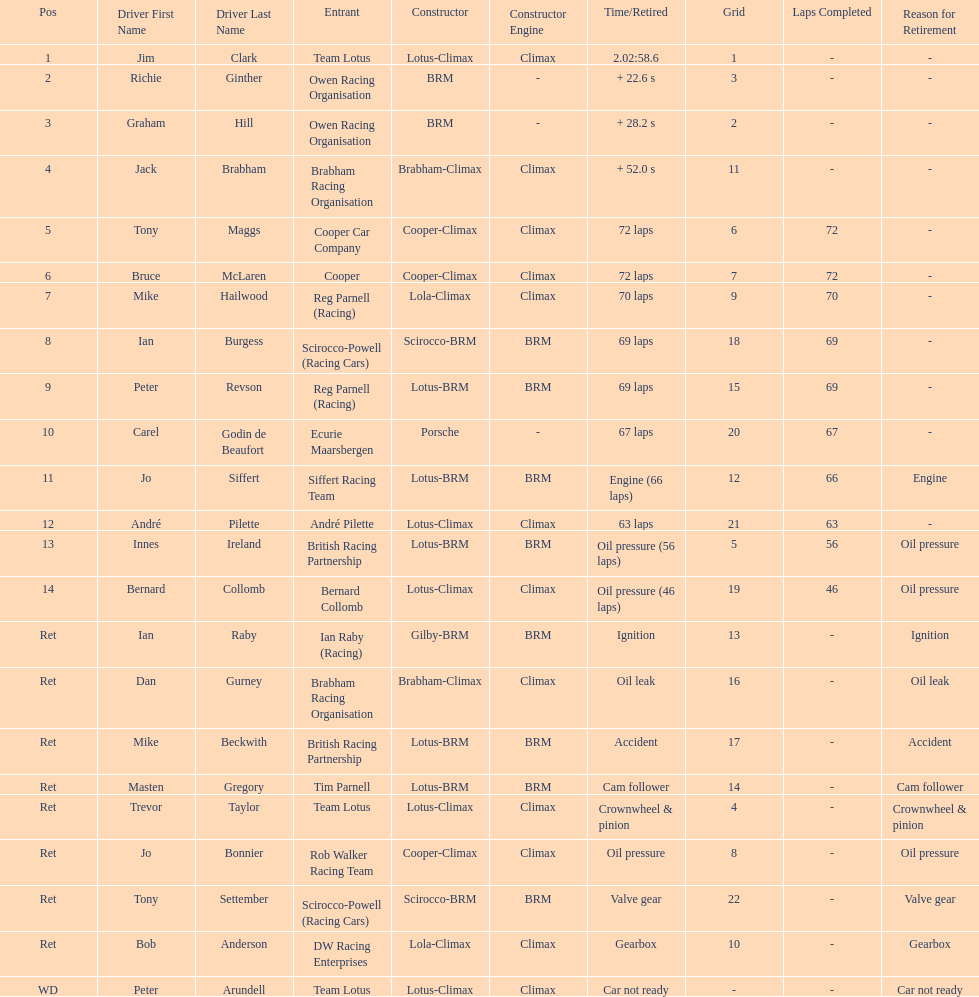What is the number of americans in the top 5? 1. 